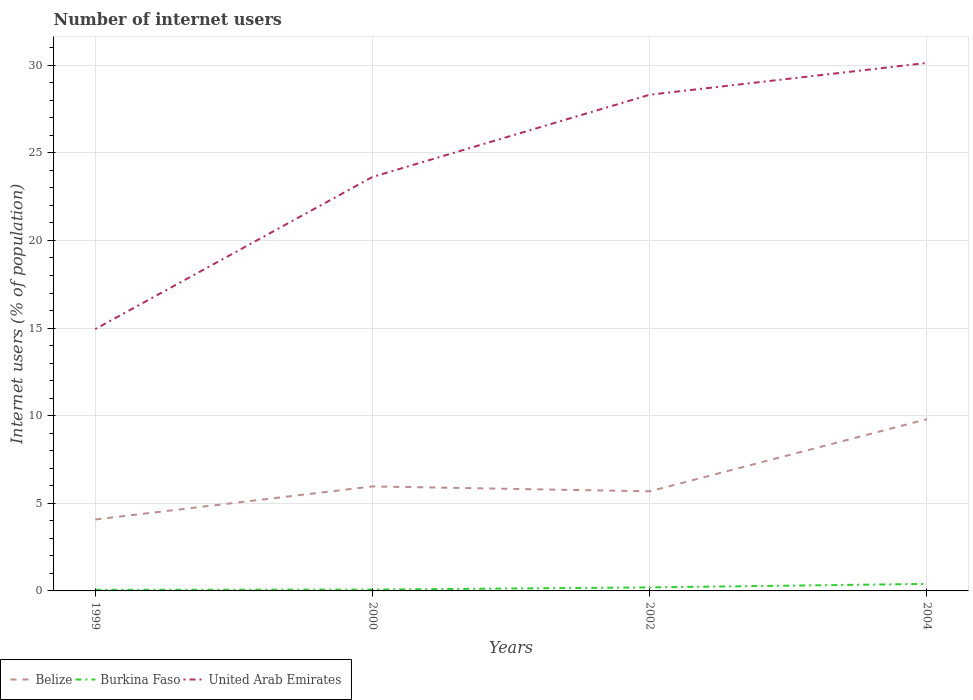Does the line corresponding to Belize intersect with the line corresponding to United Arab Emirates?
Give a very brief answer. No. Across all years, what is the maximum number of internet users in Burkina Faso?
Make the answer very short. 0.06. What is the total number of internet users in Burkina Faso in the graph?
Ensure brevity in your answer.  -0.34. What is the difference between the highest and the second highest number of internet users in Belize?
Provide a short and direct response. 5.72. Is the number of internet users in Burkina Faso strictly greater than the number of internet users in Belize over the years?
Offer a very short reply. Yes. How many lines are there?
Your answer should be very brief. 3. How many years are there in the graph?
Keep it short and to the point. 4. What is the difference between two consecutive major ticks on the Y-axis?
Your answer should be compact. 5. Does the graph contain any zero values?
Give a very brief answer. No. Does the graph contain grids?
Your answer should be compact. Yes. Where does the legend appear in the graph?
Keep it short and to the point. Bottom left. How many legend labels are there?
Make the answer very short. 3. What is the title of the graph?
Keep it short and to the point. Number of internet users. Does "Cambodia" appear as one of the legend labels in the graph?
Keep it short and to the point. No. What is the label or title of the Y-axis?
Your answer should be very brief. Internet users (% of population). What is the Internet users (% of population) in Belize in 1999?
Offer a very short reply. 4.08. What is the Internet users (% of population) of Burkina Faso in 1999?
Provide a short and direct response. 0.06. What is the Internet users (% of population) in United Arab Emirates in 1999?
Give a very brief answer. 14.94. What is the Internet users (% of population) of Belize in 2000?
Offer a terse response. 5.96. What is the Internet users (% of population) in Burkina Faso in 2000?
Offer a very short reply. 0.08. What is the Internet users (% of population) of United Arab Emirates in 2000?
Give a very brief answer. 23.63. What is the Internet users (% of population) in Belize in 2002?
Make the answer very short. 5.68. What is the Internet users (% of population) of Burkina Faso in 2002?
Your answer should be very brief. 0.2. What is the Internet users (% of population) of United Arab Emirates in 2002?
Give a very brief answer. 28.32. What is the Internet users (% of population) of Belize in 2004?
Make the answer very short. 9.8. What is the Internet users (% of population) of Burkina Faso in 2004?
Provide a succinct answer. 0.4. What is the Internet users (% of population) in United Arab Emirates in 2004?
Make the answer very short. 30.13. Across all years, what is the maximum Internet users (% of population) of Belize?
Your response must be concise. 9.8. Across all years, what is the maximum Internet users (% of population) in Burkina Faso?
Offer a terse response. 0.4. Across all years, what is the maximum Internet users (% of population) in United Arab Emirates?
Provide a succinct answer. 30.13. Across all years, what is the minimum Internet users (% of population) of Belize?
Your response must be concise. 4.08. Across all years, what is the minimum Internet users (% of population) of Burkina Faso?
Your answer should be compact. 0.06. Across all years, what is the minimum Internet users (% of population) of United Arab Emirates?
Your response must be concise. 14.94. What is the total Internet users (% of population) of Belize in the graph?
Your answer should be very brief. 25.52. What is the total Internet users (% of population) of Burkina Faso in the graph?
Offer a very short reply. 0.74. What is the total Internet users (% of population) in United Arab Emirates in the graph?
Give a very brief answer. 97.02. What is the difference between the Internet users (% of population) in Belize in 1999 and that in 2000?
Make the answer very short. -1.89. What is the difference between the Internet users (% of population) of Burkina Faso in 1999 and that in 2000?
Your response must be concise. -0.02. What is the difference between the Internet users (% of population) in United Arab Emirates in 1999 and that in 2000?
Your answer should be compact. -8.68. What is the difference between the Internet users (% of population) of Belize in 1999 and that in 2002?
Provide a short and direct response. -1.61. What is the difference between the Internet users (% of population) in Burkina Faso in 1999 and that in 2002?
Provide a short and direct response. -0.14. What is the difference between the Internet users (% of population) in United Arab Emirates in 1999 and that in 2002?
Ensure brevity in your answer.  -13.37. What is the difference between the Internet users (% of population) of Belize in 1999 and that in 2004?
Your answer should be compact. -5.72. What is the difference between the Internet users (% of population) in Burkina Faso in 1999 and that in 2004?
Provide a succinct answer. -0.34. What is the difference between the Internet users (% of population) in United Arab Emirates in 1999 and that in 2004?
Your response must be concise. -15.19. What is the difference between the Internet users (% of population) of Belize in 2000 and that in 2002?
Offer a terse response. 0.28. What is the difference between the Internet users (% of population) in Burkina Faso in 2000 and that in 2002?
Your answer should be compact. -0.12. What is the difference between the Internet users (% of population) in United Arab Emirates in 2000 and that in 2002?
Ensure brevity in your answer.  -4.69. What is the difference between the Internet users (% of population) in Belize in 2000 and that in 2004?
Your answer should be compact. -3.84. What is the difference between the Internet users (% of population) of Burkina Faso in 2000 and that in 2004?
Provide a succinct answer. -0.32. What is the difference between the Internet users (% of population) of United Arab Emirates in 2000 and that in 2004?
Keep it short and to the point. -6.51. What is the difference between the Internet users (% of population) in Belize in 2002 and that in 2004?
Your answer should be compact. -4.12. What is the difference between the Internet users (% of population) of Burkina Faso in 2002 and that in 2004?
Provide a succinct answer. -0.2. What is the difference between the Internet users (% of population) of United Arab Emirates in 2002 and that in 2004?
Your response must be concise. -1.81. What is the difference between the Internet users (% of population) of Belize in 1999 and the Internet users (% of population) of Burkina Faso in 2000?
Provide a short and direct response. 4. What is the difference between the Internet users (% of population) in Belize in 1999 and the Internet users (% of population) in United Arab Emirates in 2000?
Keep it short and to the point. -19.55. What is the difference between the Internet users (% of population) in Burkina Faso in 1999 and the Internet users (% of population) in United Arab Emirates in 2000?
Provide a short and direct response. -23.56. What is the difference between the Internet users (% of population) in Belize in 1999 and the Internet users (% of population) in Burkina Faso in 2002?
Provide a succinct answer. 3.88. What is the difference between the Internet users (% of population) in Belize in 1999 and the Internet users (% of population) in United Arab Emirates in 2002?
Offer a terse response. -24.24. What is the difference between the Internet users (% of population) of Burkina Faso in 1999 and the Internet users (% of population) of United Arab Emirates in 2002?
Keep it short and to the point. -28.25. What is the difference between the Internet users (% of population) in Belize in 1999 and the Internet users (% of population) in Burkina Faso in 2004?
Give a very brief answer. 3.68. What is the difference between the Internet users (% of population) in Belize in 1999 and the Internet users (% of population) in United Arab Emirates in 2004?
Ensure brevity in your answer.  -26.05. What is the difference between the Internet users (% of population) of Burkina Faso in 1999 and the Internet users (% of population) of United Arab Emirates in 2004?
Your response must be concise. -30.07. What is the difference between the Internet users (% of population) in Belize in 2000 and the Internet users (% of population) in Burkina Faso in 2002?
Your response must be concise. 5.76. What is the difference between the Internet users (% of population) of Belize in 2000 and the Internet users (% of population) of United Arab Emirates in 2002?
Your response must be concise. -22.35. What is the difference between the Internet users (% of population) in Burkina Faso in 2000 and the Internet users (% of population) in United Arab Emirates in 2002?
Provide a succinct answer. -28.24. What is the difference between the Internet users (% of population) in Belize in 2000 and the Internet users (% of population) in Burkina Faso in 2004?
Provide a short and direct response. 5.56. What is the difference between the Internet users (% of population) of Belize in 2000 and the Internet users (% of population) of United Arab Emirates in 2004?
Your answer should be very brief. -24.17. What is the difference between the Internet users (% of population) of Burkina Faso in 2000 and the Internet users (% of population) of United Arab Emirates in 2004?
Your response must be concise. -30.05. What is the difference between the Internet users (% of population) of Belize in 2002 and the Internet users (% of population) of Burkina Faso in 2004?
Offer a terse response. 5.28. What is the difference between the Internet users (% of population) in Belize in 2002 and the Internet users (% of population) in United Arab Emirates in 2004?
Offer a very short reply. -24.45. What is the difference between the Internet users (% of population) in Burkina Faso in 2002 and the Internet users (% of population) in United Arab Emirates in 2004?
Make the answer very short. -29.93. What is the average Internet users (% of population) of Belize per year?
Make the answer very short. 6.38. What is the average Internet users (% of population) of Burkina Faso per year?
Your answer should be compact. 0.18. What is the average Internet users (% of population) in United Arab Emirates per year?
Offer a terse response. 24.25. In the year 1999, what is the difference between the Internet users (% of population) in Belize and Internet users (% of population) in Burkina Faso?
Offer a terse response. 4.01. In the year 1999, what is the difference between the Internet users (% of population) of Belize and Internet users (% of population) of United Arab Emirates?
Give a very brief answer. -10.87. In the year 1999, what is the difference between the Internet users (% of population) in Burkina Faso and Internet users (% of population) in United Arab Emirates?
Ensure brevity in your answer.  -14.88. In the year 2000, what is the difference between the Internet users (% of population) in Belize and Internet users (% of population) in Burkina Faso?
Your answer should be compact. 5.89. In the year 2000, what is the difference between the Internet users (% of population) in Belize and Internet users (% of population) in United Arab Emirates?
Provide a succinct answer. -17.66. In the year 2000, what is the difference between the Internet users (% of population) of Burkina Faso and Internet users (% of population) of United Arab Emirates?
Offer a terse response. -23.55. In the year 2002, what is the difference between the Internet users (% of population) of Belize and Internet users (% of population) of Burkina Faso?
Give a very brief answer. 5.48. In the year 2002, what is the difference between the Internet users (% of population) in Belize and Internet users (% of population) in United Arab Emirates?
Give a very brief answer. -22.63. In the year 2002, what is the difference between the Internet users (% of population) in Burkina Faso and Internet users (% of population) in United Arab Emirates?
Provide a short and direct response. -28.12. In the year 2004, what is the difference between the Internet users (% of population) of Belize and Internet users (% of population) of Burkina Faso?
Your answer should be very brief. 9.4. In the year 2004, what is the difference between the Internet users (% of population) in Belize and Internet users (% of population) in United Arab Emirates?
Offer a terse response. -20.33. In the year 2004, what is the difference between the Internet users (% of population) in Burkina Faso and Internet users (% of population) in United Arab Emirates?
Offer a terse response. -29.73. What is the ratio of the Internet users (% of population) in Belize in 1999 to that in 2000?
Your response must be concise. 0.68. What is the ratio of the Internet users (% of population) of Burkina Faso in 1999 to that in 2000?
Offer a terse response. 0.8. What is the ratio of the Internet users (% of population) of United Arab Emirates in 1999 to that in 2000?
Provide a short and direct response. 0.63. What is the ratio of the Internet users (% of population) in Belize in 1999 to that in 2002?
Your answer should be compact. 0.72. What is the ratio of the Internet users (% of population) of Burkina Faso in 1999 to that in 2002?
Ensure brevity in your answer.  0.31. What is the ratio of the Internet users (% of population) in United Arab Emirates in 1999 to that in 2002?
Provide a short and direct response. 0.53. What is the ratio of the Internet users (% of population) of Belize in 1999 to that in 2004?
Provide a short and direct response. 0.42. What is the ratio of the Internet users (% of population) in Burkina Faso in 1999 to that in 2004?
Your answer should be compact. 0.15. What is the ratio of the Internet users (% of population) of United Arab Emirates in 1999 to that in 2004?
Keep it short and to the point. 0.5. What is the ratio of the Internet users (% of population) of Belize in 2000 to that in 2002?
Your answer should be compact. 1.05. What is the ratio of the Internet users (% of population) of Burkina Faso in 2000 to that in 2002?
Offer a terse response. 0.38. What is the ratio of the Internet users (% of population) of United Arab Emirates in 2000 to that in 2002?
Your response must be concise. 0.83. What is the ratio of the Internet users (% of population) of Belize in 2000 to that in 2004?
Provide a short and direct response. 0.61. What is the ratio of the Internet users (% of population) in Burkina Faso in 2000 to that in 2004?
Keep it short and to the point. 0.19. What is the ratio of the Internet users (% of population) in United Arab Emirates in 2000 to that in 2004?
Provide a short and direct response. 0.78. What is the ratio of the Internet users (% of population) of Belize in 2002 to that in 2004?
Provide a succinct answer. 0.58. What is the ratio of the Internet users (% of population) in Burkina Faso in 2002 to that in 2004?
Keep it short and to the point. 0.5. What is the ratio of the Internet users (% of population) in United Arab Emirates in 2002 to that in 2004?
Make the answer very short. 0.94. What is the difference between the highest and the second highest Internet users (% of population) in Belize?
Keep it short and to the point. 3.84. What is the difference between the highest and the second highest Internet users (% of population) in Burkina Faso?
Your answer should be compact. 0.2. What is the difference between the highest and the second highest Internet users (% of population) in United Arab Emirates?
Your answer should be compact. 1.81. What is the difference between the highest and the lowest Internet users (% of population) of Belize?
Give a very brief answer. 5.72. What is the difference between the highest and the lowest Internet users (% of population) of Burkina Faso?
Your response must be concise. 0.34. What is the difference between the highest and the lowest Internet users (% of population) in United Arab Emirates?
Your answer should be very brief. 15.19. 